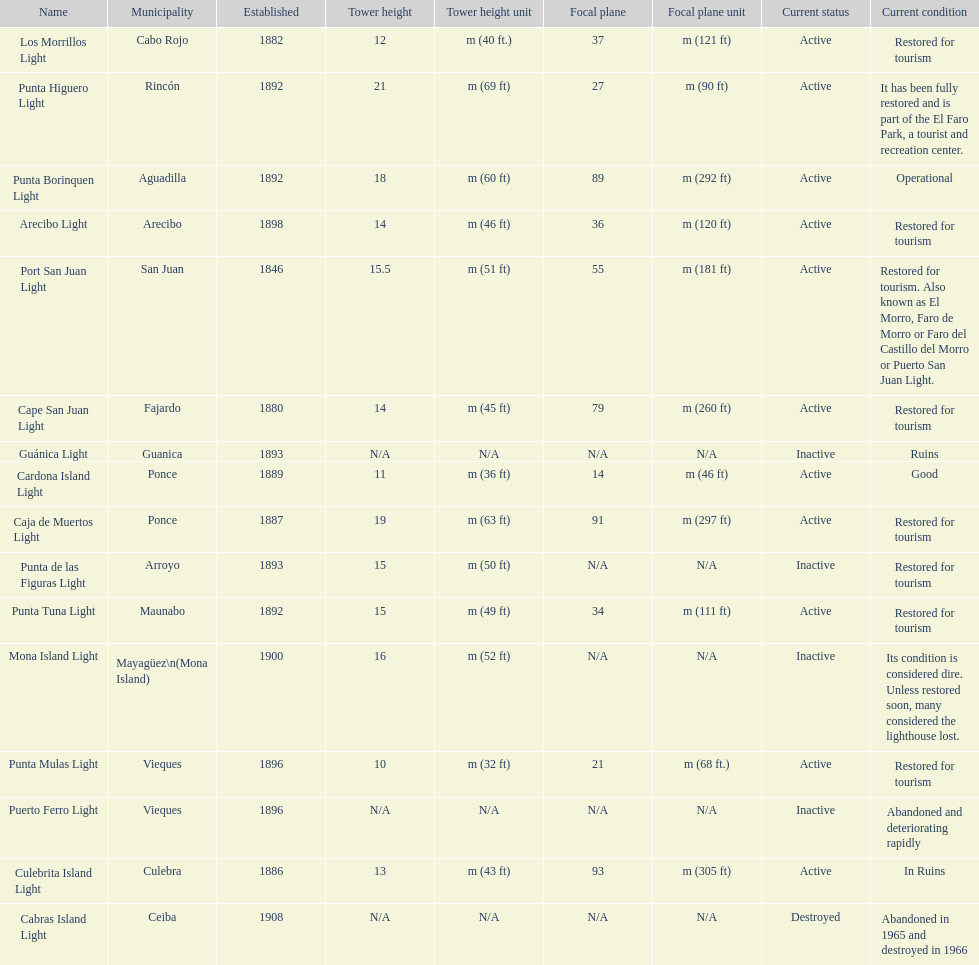Would you be able to parse every entry in this table? {'header': ['Name', 'Municipality', 'Established', 'Tower height', 'Tower height unit', 'Focal plane', 'Focal plane unit', 'Current status', 'Current condition'], 'rows': [['Los Morrillos Light', 'Cabo Rojo', '1882', '12', 'm (40 ft.)', '37', 'm (121 ft)', 'Active', 'Restored for tourism'], ['Punta Higuero Light', 'Rincón', '1892', '21', 'm (69 ft)', '27', 'm (90 ft)', 'Active', 'It has been fully restored and is part of the El Faro Park, a tourist and recreation center.'], ['Punta Borinquen Light', 'Aguadilla', '1892', '18', 'm (60 ft)', '89', 'm (292 ft)', 'Active', 'Operational'], ['Arecibo Light', 'Arecibo', '1898', '14', 'm (46 ft)', '36', 'm (120 ft)', 'Active', 'Restored for tourism'], ['Port San Juan Light', 'San Juan', '1846', '15.5', 'm (51 ft)', '55', 'm (181 ft)', 'Active', 'Restored for tourism. Also known as El Morro, Faro de Morro or Faro del Castillo del Morro or Puerto San Juan Light.'], ['Cape San Juan Light', 'Fajardo', '1880', '14', 'm (45 ft)', '79', 'm (260 ft)', 'Active', 'Restored for tourism'], ['Guánica Light', 'Guanica', '1893', 'N/A', 'N/A', 'N/A', 'N/A', 'Inactive', 'Ruins'], ['Cardona Island Light', 'Ponce', '1889', '11', 'm (36 ft)', '14', 'm (46 ft)', 'Active', 'Good'], ['Caja de Muertos Light', 'Ponce', '1887', '19', 'm (63 ft)', '91', 'm (297 ft)', 'Active', 'Restored for tourism'], ['Punta de las Figuras Light', 'Arroyo', '1893', '15', 'm (50 ft)', 'N/A', 'N/A', 'Inactive', 'Restored for tourism'], ['Punta Tuna Light', 'Maunabo', '1892', '15', 'm (49 ft)', '34', 'm (111 ft)', 'Active', 'Restored for tourism'], ['Mona Island Light', 'Mayagüez\\n(Mona Island)', '1900', '16', 'm (52 ft)', 'N/A', 'N/A', 'Inactive', 'Its condition is considered dire. Unless restored soon, many considered the lighthouse lost.'], ['Punta Mulas Light', 'Vieques', '1896', '10', 'm (32 ft)', '21', 'm (68 ft.)', 'Active', 'Restored for tourism'], ['Puerto Ferro Light', 'Vieques', '1896', 'N/A', 'N/A', 'N/A', 'N/A', 'Inactive', 'Abandoned and deteriorating rapidly'], ['Culebrita Island Light', 'Culebra', '1886', '13', 'm (43 ft)', '93', 'm (305 ft)', 'Active', 'In Ruins'], ['Cabras Island Light', 'Ceiba', '1908', 'N/A', 'N/A', 'N/A', 'N/A', 'Destroyed', 'Abandoned in 1965 and destroyed in 1966']]} Cardona island light and caja de muertos light are both located in what municipality? Ponce. 